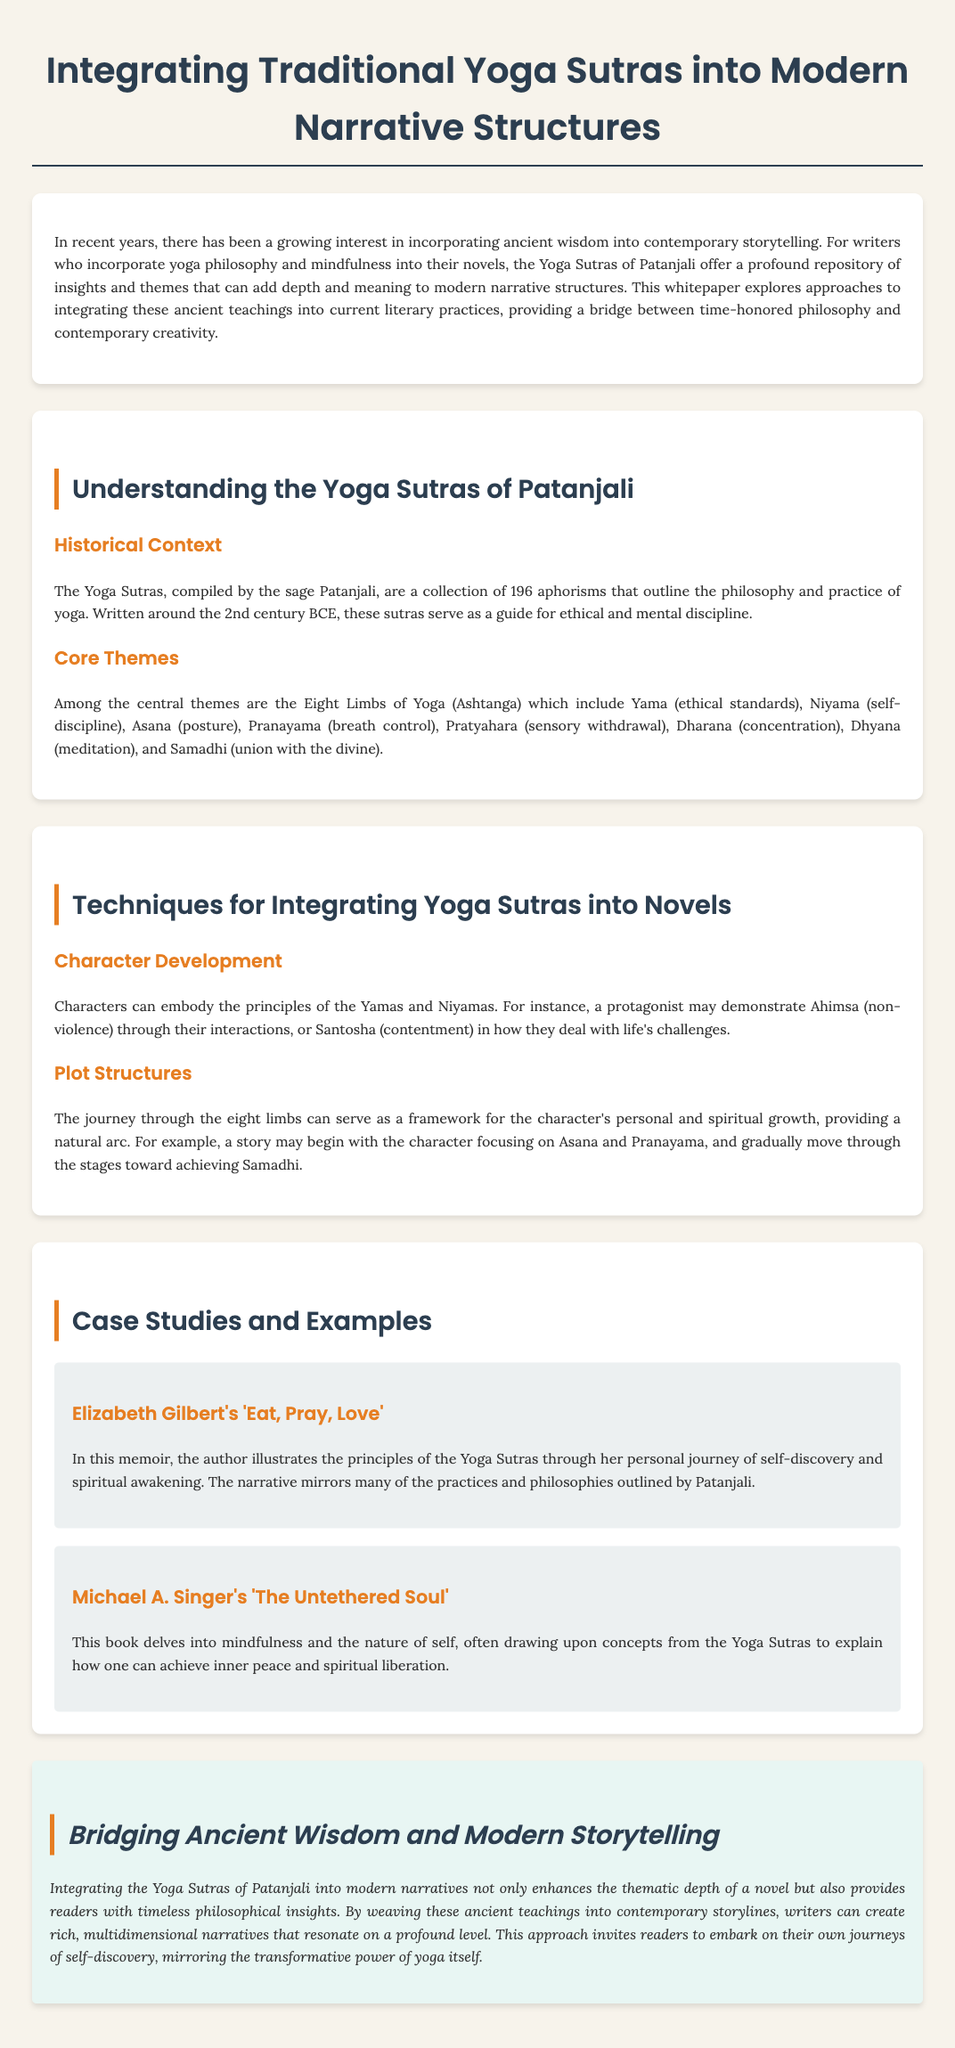What are the Yoga Sutras? The Yoga Sutras are a collection of 196 aphorisms that outline the philosophy and practice of yoga.
Answer: A collection of 196 aphorisms Who compiled the Yoga Sutras? The document states that the Yoga Sutras were compiled by the sage Patanjali.
Answer: Patanjali What are the Eight Limbs of Yoga? The Eight Limbs of Yoga are Yama, Niyama, Asana, Pranayama, Pratyahara, Dharana, Dhyana, and Samadhi.
Answer: Yama, Niyama, Asana, Pranayama, Pratyahara, Dharana, Dhyana, Samadhi Which book illustrates the principles of the Yoga Sutras through personal journey? Elizabeth Gilbert's memoir 'Eat, Pray, Love' illustrates the principles of the Yoga Sutras.
Answer: 'Eat, Pray, Love' What can characters embody to reflect the Yoga Sutras? Characters can embody the principles of the Yamas and Niyamas.
Answer: Yamas and Niyamas How can the journey through the eight limbs serve a character? The journey through the eight limbs can serve as a framework for the character's personal and spiritual growth.
Answer: Framework for personal and spiritual growth What does the whitepaper encourage writers to create? The whitepaper encourages writers to create rich, multidimensional narratives.
Answer: Rich, multidimensional narratives What is one example of a book that draws upon concepts from the Yoga Sutras? Michael A. Singer's 'The Untethered Soul' draws upon concepts from the Yoga Sutras.
Answer: 'The Untethered Soul' 